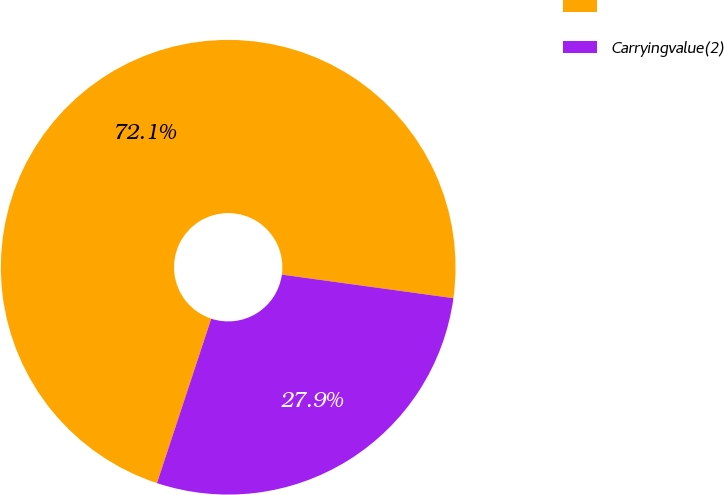Convert chart to OTSL. <chart><loc_0><loc_0><loc_500><loc_500><pie_chart><ecel><fcel>Carryingvalue(2)<nl><fcel>72.1%<fcel>27.9%<nl></chart> 